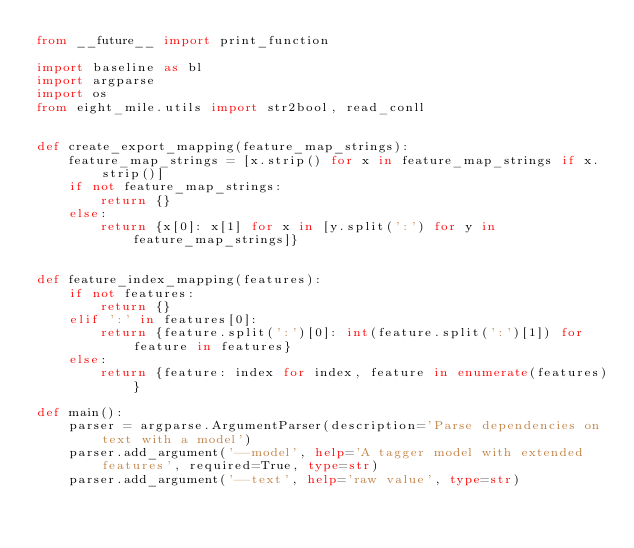Convert code to text. <code><loc_0><loc_0><loc_500><loc_500><_Python_>from __future__ import print_function

import baseline as bl
import argparse
import os
from eight_mile.utils import str2bool, read_conll


def create_export_mapping(feature_map_strings):
    feature_map_strings = [x.strip() for x in feature_map_strings if x.strip()]
    if not feature_map_strings:
        return {}
    else:
        return {x[0]: x[1] for x in [y.split(':') for y in feature_map_strings]}


def feature_index_mapping(features):
    if not features:
        return {}
    elif ':' in features[0]:
        return {feature.split(':')[0]: int(feature.split(':')[1]) for feature in features}
    else:
        return {feature: index for index, feature in enumerate(features)}

def main():
    parser = argparse.ArgumentParser(description='Parse dependencies on text with a model')
    parser.add_argument('--model', help='A tagger model with extended features', required=True, type=str)
    parser.add_argument('--text', help='raw value', type=str)</code> 